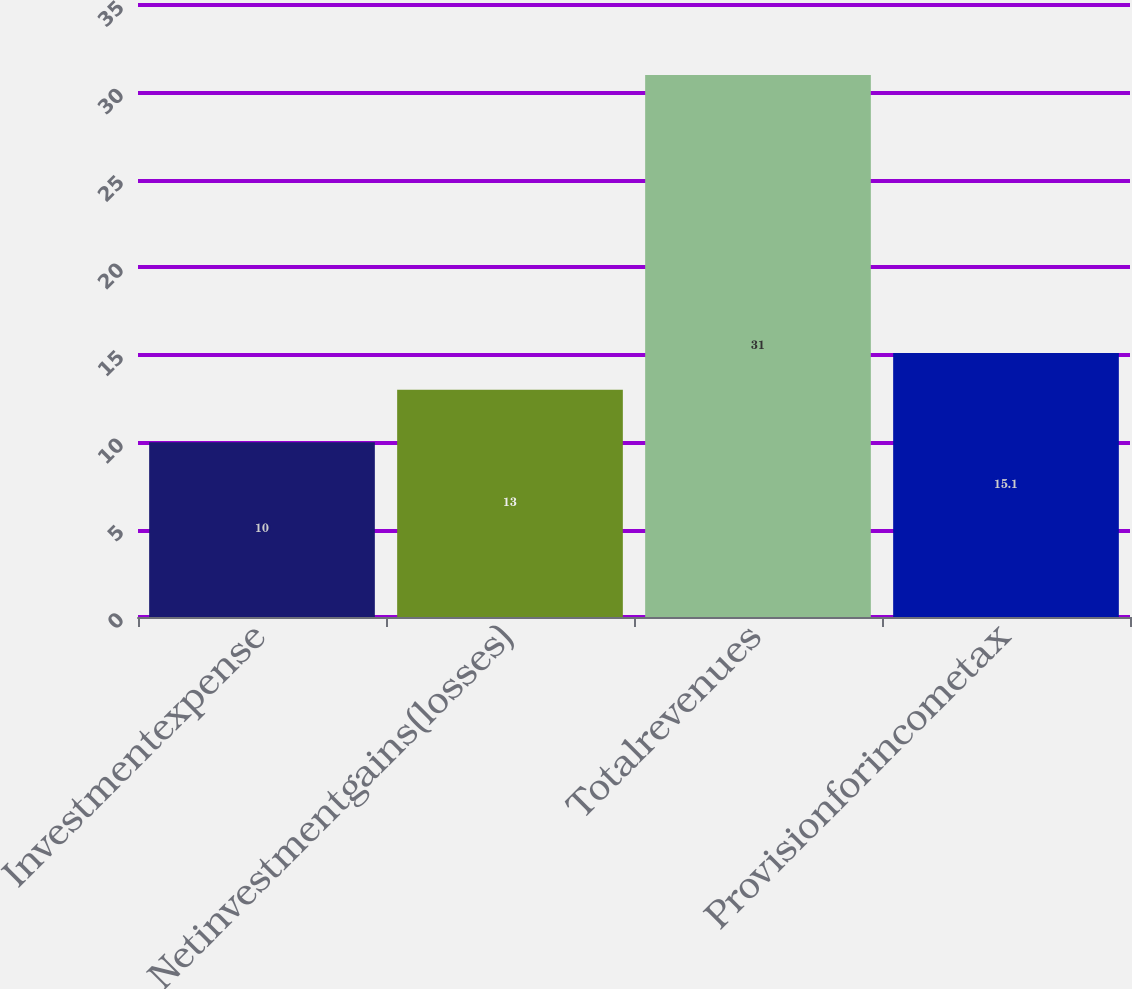Convert chart. <chart><loc_0><loc_0><loc_500><loc_500><bar_chart><fcel>Investmentexpense<fcel>Netinvestmentgains(losses)<fcel>Totalrevenues<fcel>Provisionforincometax<nl><fcel>10<fcel>13<fcel>31<fcel>15.1<nl></chart> 